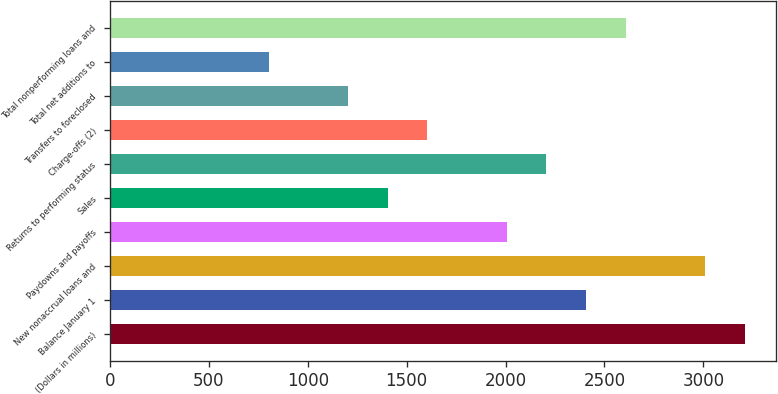<chart> <loc_0><loc_0><loc_500><loc_500><bar_chart><fcel>(Dollars in millions)<fcel>Balance January 1<fcel>New nonaccrual loans and<fcel>Paydowns and payoffs<fcel>Sales<fcel>Returns to performing status<fcel>Charge-offs (2)<fcel>Transfers to foreclosed<fcel>Total net additions to<fcel>Total nonperforming loans and<nl><fcel>3207.9<fcel>2405.98<fcel>3007.42<fcel>2005.02<fcel>1403.58<fcel>2205.5<fcel>1604.06<fcel>1203.1<fcel>802.14<fcel>2606.46<nl></chart> 